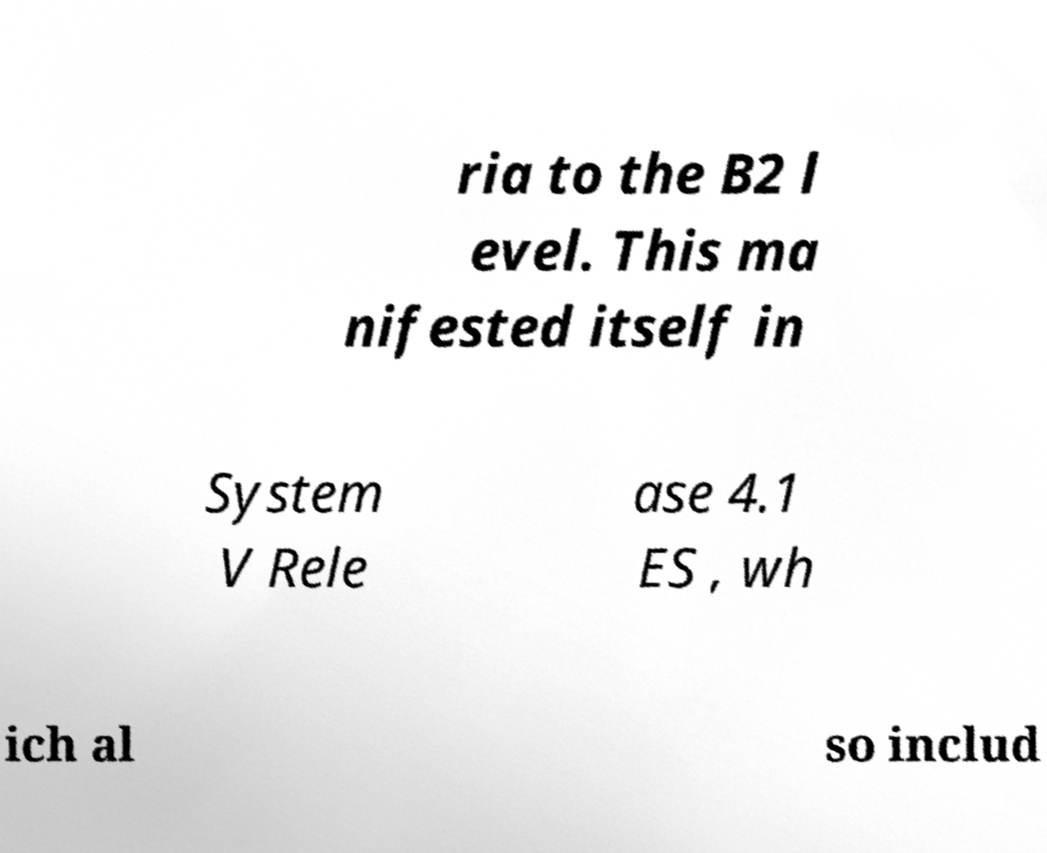Please read and relay the text visible in this image. What does it say? ria to the B2 l evel. This ma nifested itself in System V Rele ase 4.1 ES , wh ich al so includ 